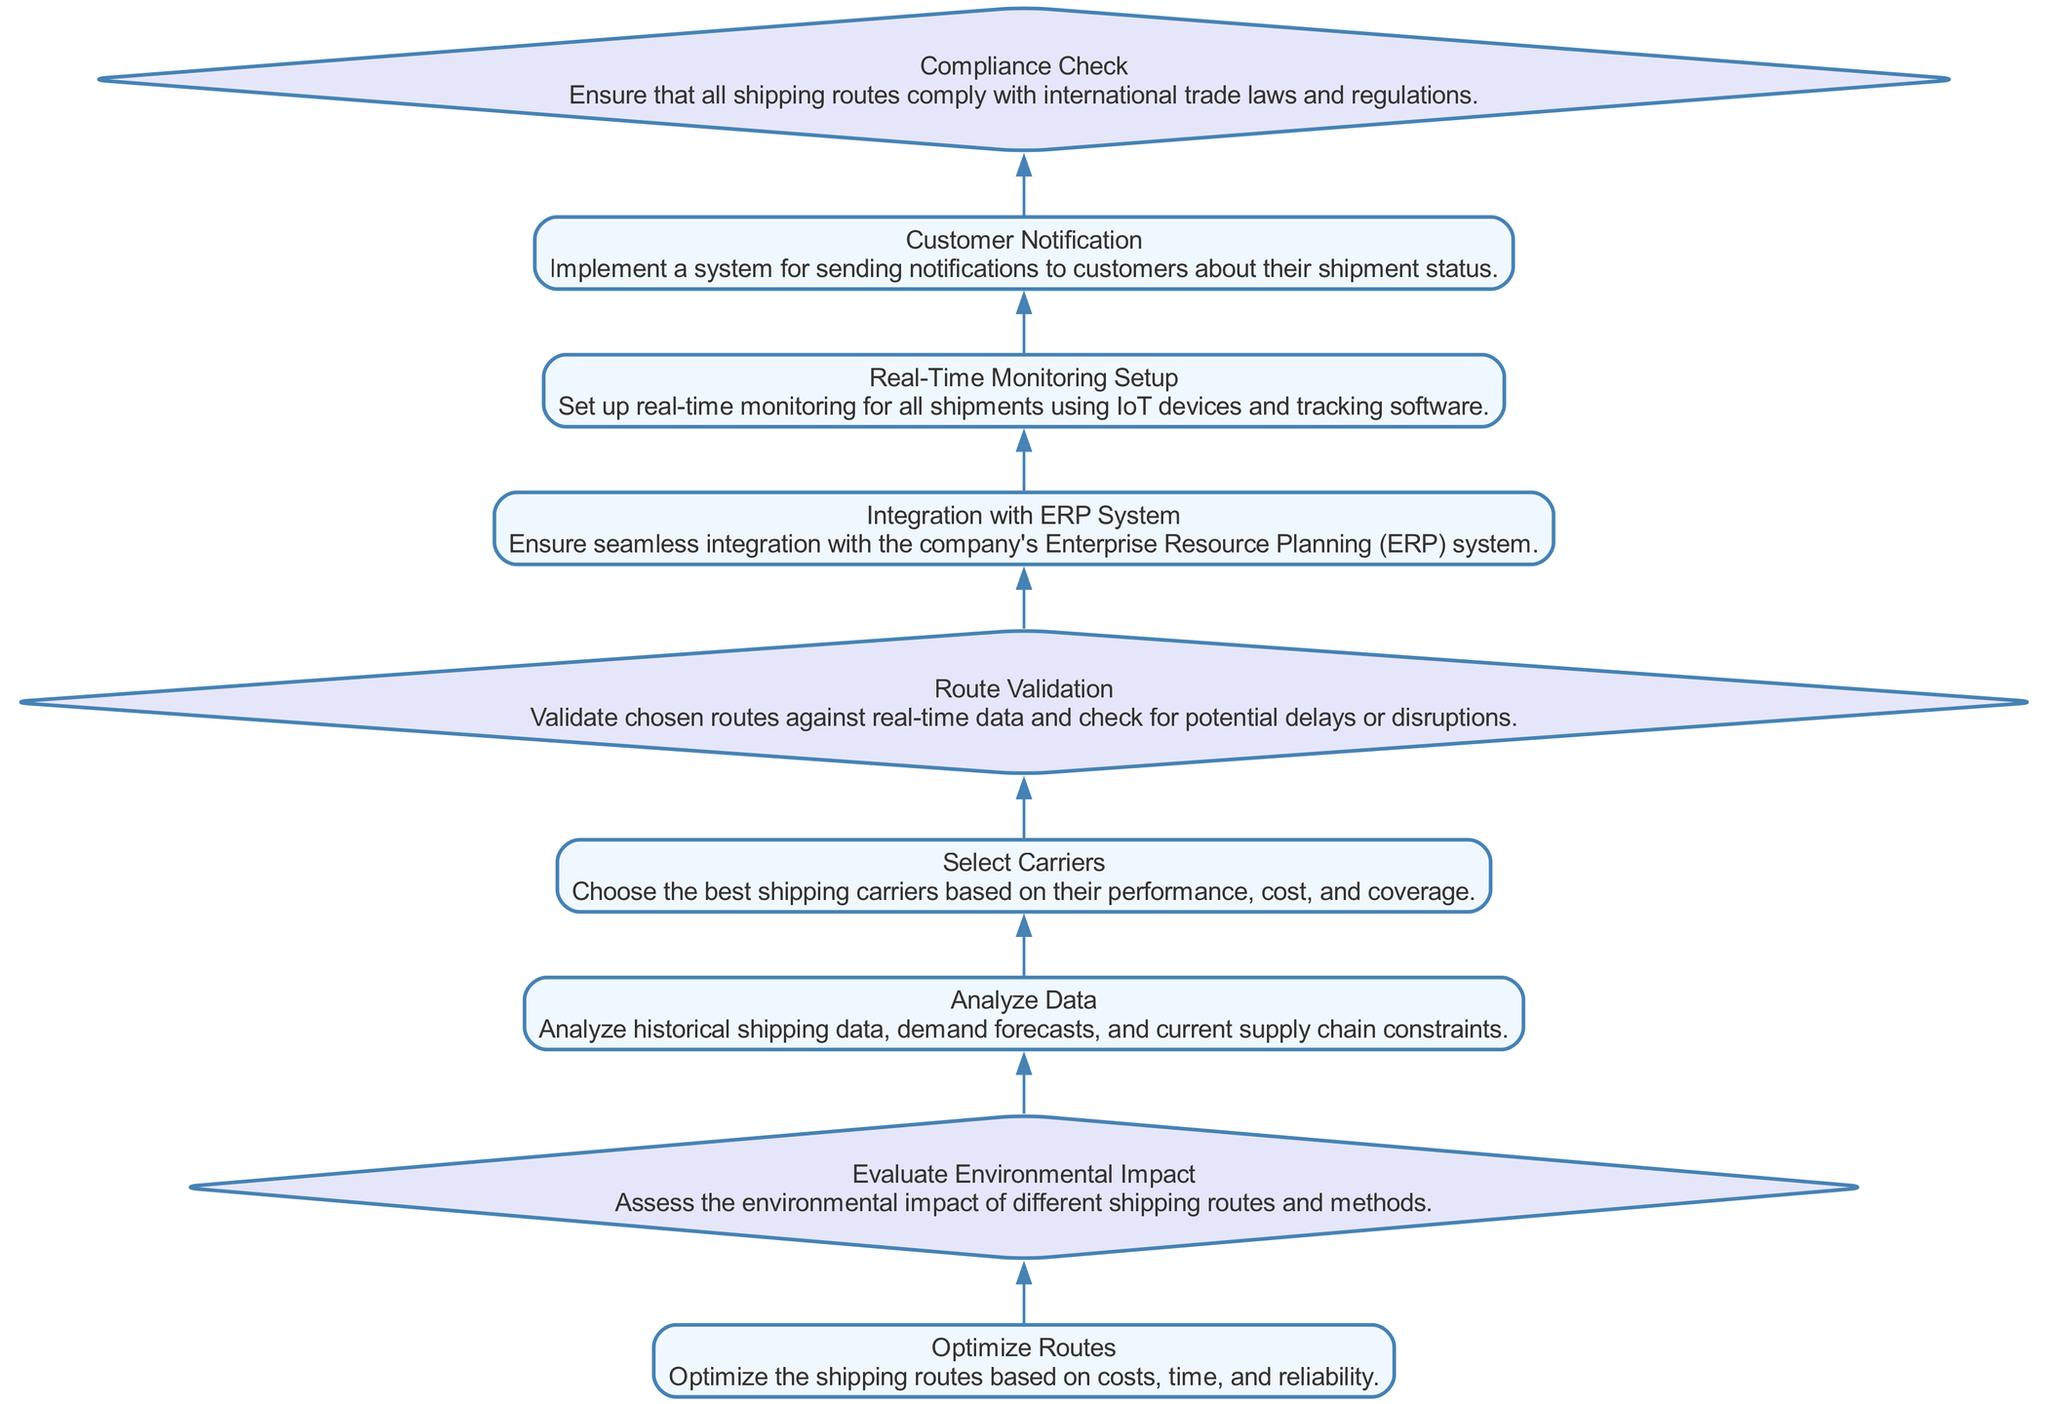What is the first process node in the diagram? The first process node identified in the diagram is "Optimize Routes". This can be found by looking at the very bottom of the flowchart, where the process steps begin.
Answer: Optimize Routes How many decision nodes are present in the diagram? By examining the diagram, there are three decision nodes: "Evaluate Environmental Impact", "Route Validation", and "Compliance Check". Counting these gives the total number.
Answer: 3 What is the last process node in the flow? The last process node in the sequence is "Customer Notification". This is found by moving up through the flowchart until reaching the final process action before the top.
Answer: Customer Notification Which node comes after "Select Carriers"? The node that directly follows "Select Carriers" is "Route Validation". The relationship can be determined by following the flow upward in the diagram from "Select Carriers".
Answer: Route Validation What are the two types of elements in the diagram? The two types of elements identified in the diagram are "process" and "decision". These types can be found by examining the node characteristics represented visually.
Answer: process and decision What is required before "Route Validation" can occur? Before "Route Validation" can occur, "Select Carriers" must be completed. The logical flow in the diagram indicates that "Select Carriers" is a prerequisite for "Route Validation".
Answer: Select Carriers Which step ensures compliance with international trade laws? The step that ensures compliance with international trade laws is "Compliance Check". This is explicitly stated as a decision node in the flowchart that addresses compliance.
Answer: Compliance Check What type of setup is established after real-time monitoring? After real-time monitoring, a system for "Customer Notification" is established. This sequence is derived from the upward flow in the diagram which links these two processes.
Answer: Customer Notification 